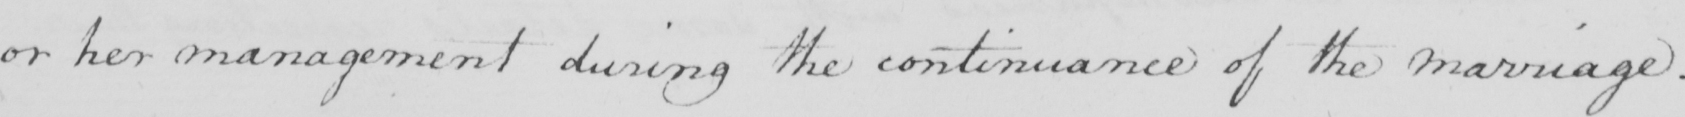What is written in this line of handwriting? or her management during the continuance of the marriage . 